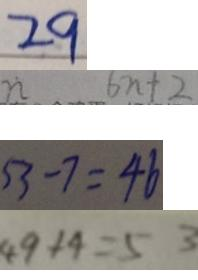<formula> <loc_0><loc_0><loc_500><loc_500>2 9 
 n 6 n + 2 
 5 3 - 7 = 4 6 
 4 9 + 4 = 5 3</formula> 